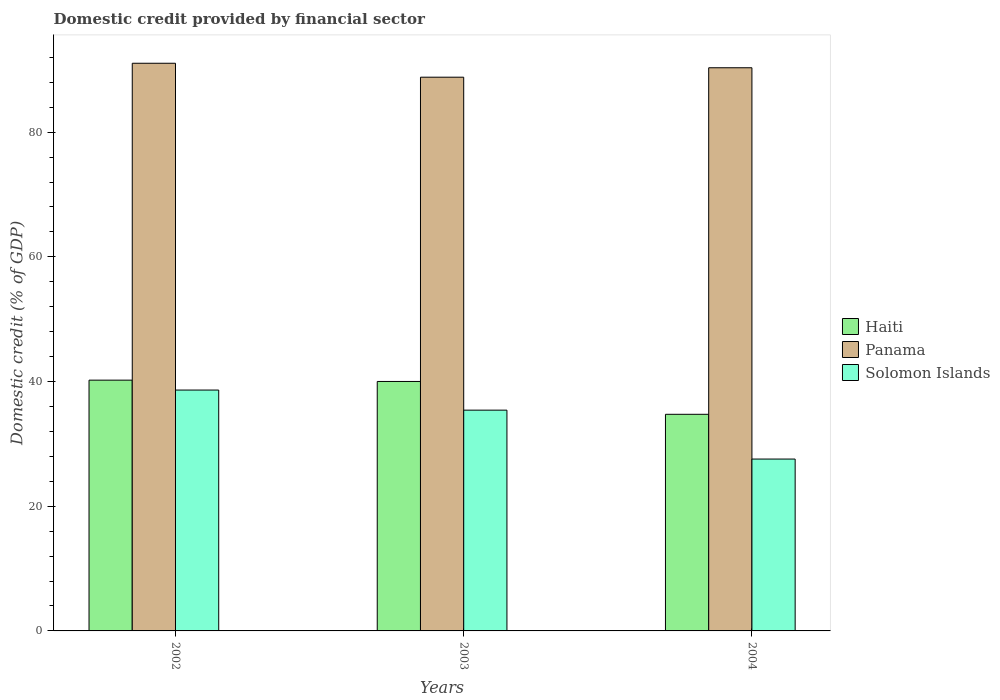How many groups of bars are there?
Give a very brief answer. 3. Are the number of bars per tick equal to the number of legend labels?
Your response must be concise. Yes. What is the label of the 3rd group of bars from the left?
Your answer should be very brief. 2004. What is the domestic credit in Haiti in 2002?
Make the answer very short. 40.22. Across all years, what is the maximum domestic credit in Haiti?
Make the answer very short. 40.22. Across all years, what is the minimum domestic credit in Solomon Islands?
Provide a succinct answer. 27.57. In which year was the domestic credit in Solomon Islands minimum?
Provide a succinct answer. 2004. What is the total domestic credit in Haiti in the graph?
Keep it short and to the point. 114.98. What is the difference between the domestic credit in Panama in 2002 and that in 2004?
Ensure brevity in your answer.  0.72. What is the difference between the domestic credit in Solomon Islands in 2003 and the domestic credit in Haiti in 2002?
Give a very brief answer. -4.81. What is the average domestic credit in Haiti per year?
Ensure brevity in your answer.  38.33. In the year 2003, what is the difference between the domestic credit in Solomon Islands and domestic credit in Panama?
Your response must be concise. -53.4. In how many years, is the domestic credit in Haiti greater than 4 %?
Keep it short and to the point. 3. What is the ratio of the domestic credit in Panama in 2002 to that in 2004?
Your answer should be compact. 1.01. Is the domestic credit in Panama in 2002 less than that in 2004?
Your answer should be very brief. No. What is the difference between the highest and the second highest domestic credit in Solomon Islands?
Keep it short and to the point. 3.22. What is the difference between the highest and the lowest domestic credit in Solomon Islands?
Your answer should be compact. 11.07. In how many years, is the domestic credit in Solomon Islands greater than the average domestic credit in Solomon Islands taken over all years?
Your response must be concise. 2. What does the 3rd bar from the left in 2002 represents?
Your answer should be very brief. Solomon Islands. What does the 3rd bar from the right in 2002 represents?
Your answer should be very brief. Haiti. Is it the case that in every year, the sum of the domestic credit in Solomon Islands and domestic credit in Haiti is greater than the domestic credit in Panama?
Provide a succinct answer. No. How many bars are there?
Ensure brevity in your answer.  9. Are the values on the major ticks of Y-axis written in scientific E-notation?
Your answer should be very brief. No. Does the graph contain any zero values?
Provide a succinct answer. No. Does the graph contain grids?
Give a very brief answer. No. Where does the legend appear in the graph?
Provide a succinct answer. Center right. How many legend labels are there?
Your answer should be compact. 3. How are the legend labels stacked?
Your answer should be very brief. Vertical. What is the title of the graph?
Offer a terse response. Domestic credit provided by financial sector. What is the label or title of the X-axis?
Your answer should be very brief. Years. What is the label or title of the Y-axis?
Provide a succinct answer. Domestic credit (% of GDP). What is the Domestic credit (% of GDP) in Haiti in 2002?
Keep it short and to the point. 40.22. What is the Domestic credit (% of GDP) of Panama in 2002?
Your response must be concise. 91.05. What is the Domestic credit (% of GDP) of Solomon Islands in 2002?
Your answer should be compact. 38.64. What is the Domestic credit (% of GDP) in Haiti in 2003?
Ensure brevity in your answer.  40.01. What is the Domestic credit (% of GDP) of Panama in 2003?
Offer a terse response. 88.82. What is the Domestic credit (% of GDP) of Solomon Islands in 2003?
Keep it short and to the point. 35.41. What is the Domestic credit (% of GDP) of Haiti in 2004?
Your response must be concise. 34.74. What is the Domestic credit (% of GDP) in Panama in 2004?
Offer a terse response. 90.33. What is the Domestic credit (% of GDP) of Solomon Islands in 2004?
Provide a short and direct response. 27.57. Across all years, what is the maximum Domestic credit (% of GDP) in Haiti?
Offer a very short reply. 40.22. Across all years, what is the maximum Domestic credit (% of GDP) of Panama?
Offer a very short reply. 91.05. Across all years, what is the maximum Domestic credit (% of GDP) of Solomon Islands?
Your answer should be very brief. 38.64. Across all years, what is the minimum Domestic credit (% of GDP) of Haiti?
Give a very brief answer. 34.74. Across all years, what is the minimum Domestic credit (% of GDP) of Panama?
Keep it short and to the point. 88.82. Across all years, what is the minimum Domestic credit (% of GDP) of Solomon Islands?
Offer a very short reply. 27.57. What is the total Domestic credit (% of GDP) in Haiti in the graph?
Your response must be concise. 114.98. What is the total Domestic credit (% of GDP) in Panama in the graph?
Your answer should be compact. 270.2. What is the total Domestic credit (% of GDP) in Solomon Islands in the graph?
Offer a very short reply. 101.62. What is the difference between the Domestic credit (% of GDP) in Haiti in 2002 and that in 2003?
Your response must be concise. 0.21. What is the difference between the Domestic credit (% of GDP) of Panama in 2002 and that in 2003?
Make the answer very short. 2.24. What is the difference between the Domestic credit (% of GDP) of Solomon Islands in 2002 and that in 2003?
Offer a terse response. 3.22. What is the difference between the Domestic credit (% of GDP) in Haiti in 2002 and that in 2004?
Make the answer very short. 5.48. What is the difference between the Domestic credit (% of GDP) in Panama in 2002 and that in 2004?
Provide a short and direct response. 0.72. What is the difference between the Domestic credit (% of GDP) of Solomon Islands in 2002 and that in 2004?
Make the answer very short. 11.07. What is the difference between the Domestic credit (% of GDP) in Haiti in 2003 and that in 2004?
Keep it short and to the point. 5.27. What is the difference between the Domestic credit (% of GDP) of Panama in 2003 and that in 2004?
Keep it short and to the point. -1.52. What is the difference between the Domestic credit (% of GDP) of Solomon Islands in 2003 and that in 2004?
Your answer should be very brief. 7.85. What is the difference between the Domestic credit (% of GDP) of Haiti in 2002 and the Domestic credit (% of GDP) of Panama in 2003?
Your answer should be compact. -48.59. What is the difference between the Domestic credit (% of GDP) of Haiti in 2002 and the Domestic credit (% of GDP) of Solomon Islands in 2003?
Provide a succinct answer. 4.81. What is the difference between the Domestic credit (% of GDP) in Panama in 2002 and the Domestic credit (% of GDP) in Solomon Islands in 2003?
Provide a short and direct response. 55.64. What is the difference between the Domestic credit (% of GDP) in Haiti in 2002 and the Domestic credit (% of GDP) in Panama in 2004?
Offer a terse response. -50.11. What is the difference between the Domestic credit (% of GDP) in Haiti in 2002 and the Domestic credit (% of GDP) in Solomon Islands in 2004?
Provide a short and direct response. 12.66. What is the difference between the Domestic credit (% of GDP) in Panama in 2002 and the Domestic credit (% of GDP) in Solomon Islands in 2004?
Offer a very short reply. 63.49. What is the difference between the Domestic credit (% of GDP) in Haiti in 2003 and the Domestic credit (% of GDP) in Panama in 2004?
Offer a very short reply. -50.32. What is the difference between the Domestic credit (% of GDP) of Haiti in 2003 and the Domestic credit (% of GDP) of Solomon Islands in 2004?
Offer a terse response. 12.45. What is the difference between the Domestic credit (% of GDP) in Panama in 2003 and the Domestic credit (% of GDP) in Solomon Islands in 2004?
Your response must be concise. 61.25. What is the average Domestic credit (% of GDP) in Haiti per year?
Your answer should be compact. 38.33. What is the average Domestic credit (% of GDP) of Panama per year?
Make the answer very short. 90.07. What is the average Domestic credit (% of GDP) in Solomon Islands per year?
Keep it short and to the point. 33.87. In the year 2002, what is the difference between the Domestic credit (% of GDP) in Haiti and Domestic credit (% of GDP) in Panama?
Provide a short and direct response. -50.83. In the year 2002, what is the difference between the Domestic credit (% of GDP) of Haiti and Domestic credit (% of GDP) of Solomon Islands?
Your response must be concise. 1.59. In the year 2002, what is the difference between the Domestic credit (% of GDP) in Panama and Domestic credit (% of GDP) in Solomon Islands?
Keep it short and to the point. 52.42. In the year 2003, what is the difference between the Domestic credit (% of GDP) of Haiti and Domestic credit (% of GDP) of Panama?
Provide a succinct answer. -48.8. In the year 2003, what is the difference between the Domestic credit (% of GDP) of Haiti and Domestic credit (% of GDP) of Solomon Islands?
Your response must be concise. 4.6. In the year 2003, what is the difference between the Domestic credit (% of GDP) of Panama and Domestic credit (% of GDP) of Solomon Islands?
Provide a short and direct response. 53.4. In the year 2004, what is the difference between the Domestic credit (% of GDP) in Haiti and Domestic credit (% of GDP) in Panama?
Offer a terse response. -55.59. In the year 2004, what is the difference between the Domestic credit (% of GDP) of Haiti and Domestic credit (% of GDP) of Solomon Islands?
Provide a succinct answer. 7.18. In the year 2004, what is the difference between the Domestic credit (% of GDP) in Panama and Domestic credit (% of GDP) in Solomon Islands?
Offer a very short reply. 62.76. What is the ratio of the Domestic credit (% of GDP) of Haiti in 2002 to that in 2003?
Provide a succinct answer. 1.01. What is the ratio of the Domestic credit (% of GDP) of Panama in 2002 to that in 2003?
Offer a terse response. 1.03. What is the ratio of the Domestic credit (% of GDP) in Solomon Islands in 2002 to that in 2003?
Offer a very short reply. 1.09. What is the ratio of the Domestic credit (% of GDP) in Haiti in 2002 to that in 2004?
Offer a very short reply. 1.16. What is the ratio of the Domestic credit (% of GDP) of Solomon Islands in 2002 to that in 2004?
Your answer should be very brief. 1.4. What is the ratio of the Domestic credit (% of GDP) in Haiti in 2003 to that in 2004?
Provide a succinct answer. 1.15. What is the ratio of the Domestic credit (% of GDP) in Panama in 2003 to that in 2004?
Provide a succinct answer. 0.98. What is the ratio of the Domestic credit (% of GDP) of Solomon Islands in 2003 to that in 2004?
Offer a terse response. 1.28. What is the difference between the highest and the second highest Domestic credit (% of GDP) in Haiti?
Offer a very short reply. 0.21. What is the difference between the highest and the second highest Domestic credit (% of GDP) of Panama?
Your answer should be compact. 0.72. What is the difference between the highest and the second highest Domestic credit (% of GDP) in Solomon Islands?
Offer a terse response. 3.22. What is the difference between the highest and the lowest Domestic credit (% of GDP) in Haiti?
Your answer should be very brief. 5.48. What is the difference between the highest and the lowest Domestic credit (% of GDP) of Panama?
Your answer should be very brief. 2.24. What is the difference between the highest and the lowest Domestic credit (% of GDP) in Solomon Islands?
Provide a short and direct response. 11.07. 